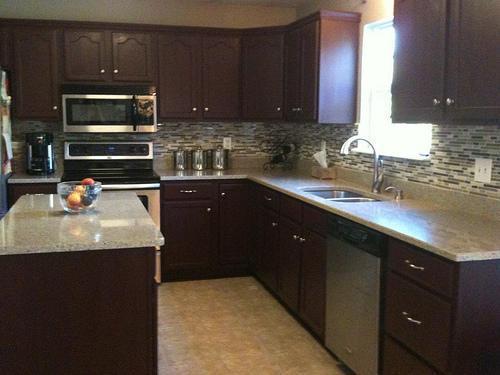How many ovens are there?
Give a very brief answer. 1. 